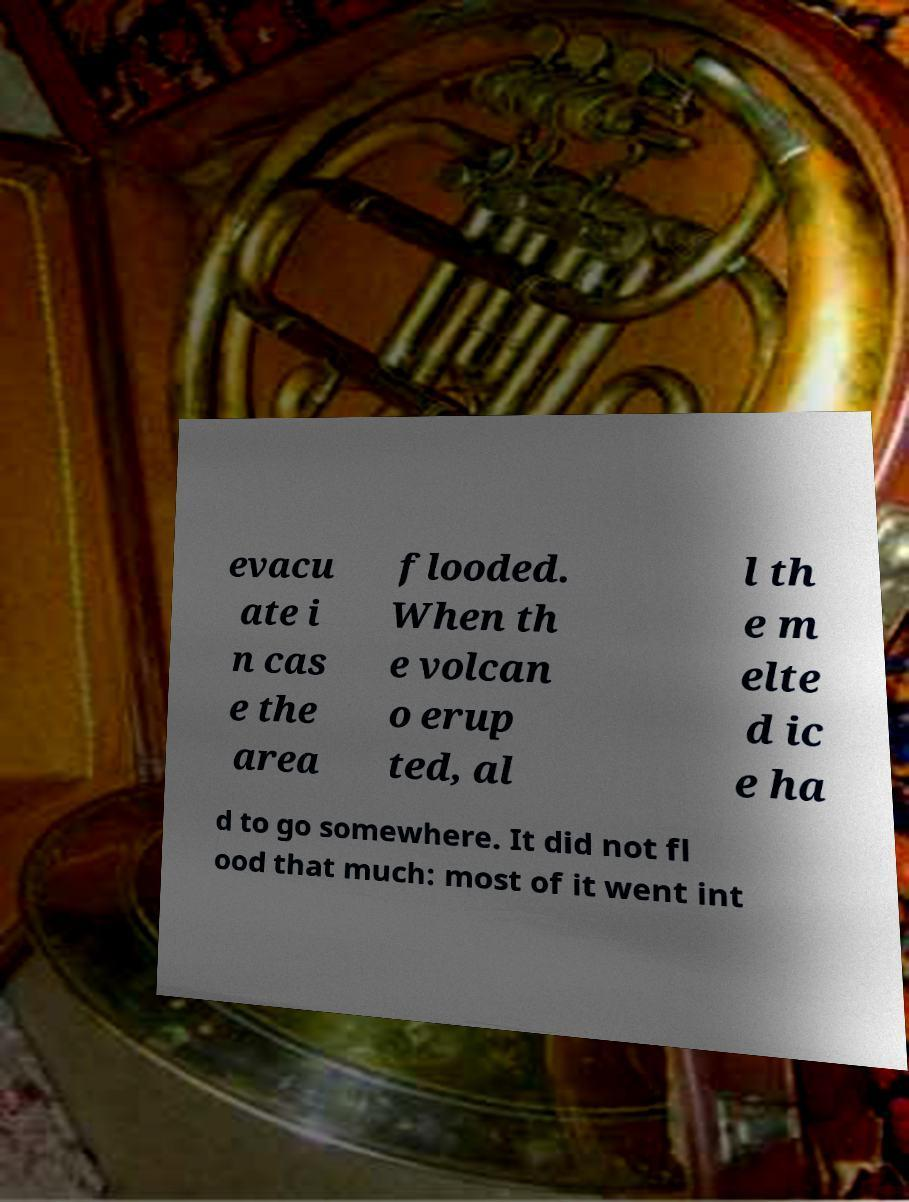Please identify and transcribe the text found in this image. evacu ate i n cas e the area flooded. When th e volcan o erup ted, al l th e m elte d ic e ha d to go somewhere. It did not fl ood that much: most of it went int 